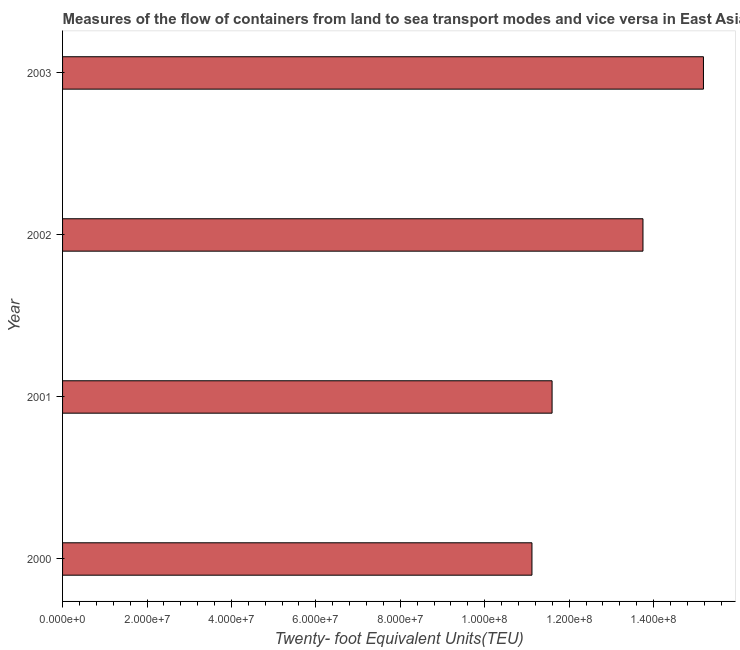What is the title of the graph?
Your answer should be compact. Measures of the flow of containers from land to sea transport modes and vice versa in East Asia (all income levels). What is the label or title of the X-axis?
Your answer should be very brief. Twenty- foot Equivalent Units(TEU). What is the container port traffic in 2002?
Offer a very short reply. 1.37e+08. Across all years, what is the maximum container port traffic?
Make the answer very short. 1.52e+08. Across all years, what is the minimum container port traffic?
Keep it short and to the point. 1.11e+08. What is the sum of the container port traffic?
Provide a succinct answer. 5.16e+08. What is the difference between the container port traffic in 2001 and 2002?
Provide a short and direct response. -2.15e+07. What is the average container port traffic per year?
Your answer should be very brief. 1.29e+08. What is the median container port traffic?
Offer a terse response. 1.27e+08. What is the ratio of the container port traffic in 2002 to that in 2003?
Offer a very short reply. 0.91. What is the difference between the highest and the second highest container port traffic?
Provide a short and direct response. 1.43e+07. What is the difference between the highest and the lowest container port traffic?
Offer a terse response. 4.06e+07. Are all the bars in the graph horizontal?
Your answer should be compact. Yes. How many years are there in the graph?
Your response must be concise. 4. What is the difference between two consecutive major ticks on the X-axis?
Keep it short and to the point. 2.00e+07. What is the Twenty- foot Equivalent Units(TEU) of 2000?
Offer a very short reply. 1.11e+08. What is the Twenty- foot Equivalent Units(TEU) of 2001?
Your answer should be compact. 1.16e+08. What is the Twenty- foot Equivalent Units(TEU) in 2002?
Make the answer very short. 1.37e+08. What is the Twenty- foot Equivalent Units(TEU) in 2003?
Offer a very short reply. 1.52e+08. What is the difference between the Twenty- foot Equivalent Units(TEU) in 2000 and 2001?
Provide a succinct answer. -4.77e+06. What is the difference between the Twenty- foot Equivalent Units(TEU) in 2000 and 2002?
Your answer should be very brief. -2.63e+07. What is the difference between the Twenty- foot Equivalent Units(TEU) in 2000 and 2003?
Provide a succinct answer. -4.06e+07. What is the difference between the Twenty- foot Equivalent Units(TEU) in 2001 and 2002?
Give a very brief answer. -2.15e+07. What is the difference between the Twenty- foot Equivalent Units(TEU) in 2001 and 2003?
Provide a succinct answer. -3.59e+07. What is the difference between the Twenty- foot Equivalent Units(TEU) in 2002 and 2003?
Your response must be concise. -1.43e+07. What is the ratio of the Twenty- foot Equivalent Units(TEU) in 2000 to that in 2002?
Your answer should be compact. 0.81. What is the ratio of the Twenty- foot Equivalent Units(TEU) in 2000 to that in 2003?
Keep it short and to the point. 0.73. What is the ratio of the Twenty- foot Equivalent Units(TEU) in 2001 to that in 2002?
Offer a terse response. 0.84. What is the ratio of the Twenty- foot Equivalent Units(TEU) in 2001 to that in 2003?
Your response must be concise. 0.76. What is the ratio of the Twenty- foot Equivalent Units(TEU) in 2002 to that in 2003?
Make the answer very short. 0.91. 